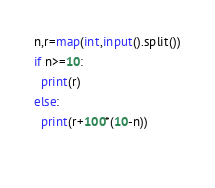Convert code to text. <code><loc_0><loc_0><loc_500><loc_500><_Python_>n,r=map(int,input().split())
if n>=10:
  print(r)
else:
  print(r+100*(10-n))
  </code> 